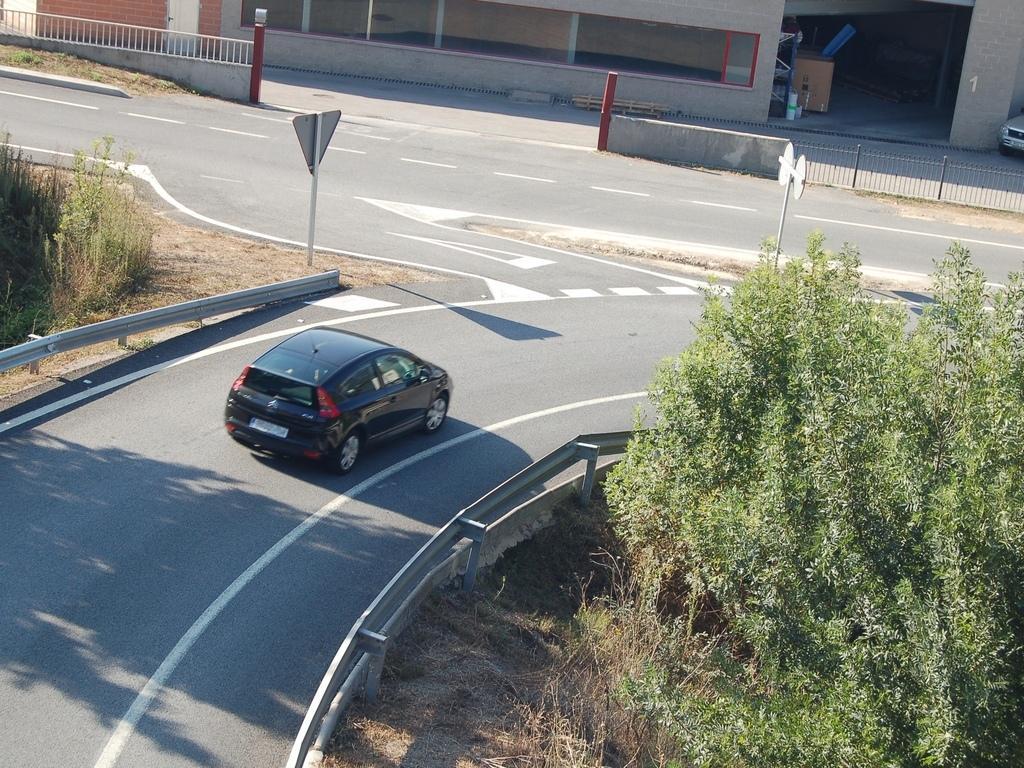How would you summarize this image in a sentence or two? This picture is clicked outside the city. In this picture, we see a black car moving on the road. On either side of the road, we see trees and caution boards. In the background, we see an iron railing and the building. On the right side, we see a car parked. Beside that, we see a carton box. 